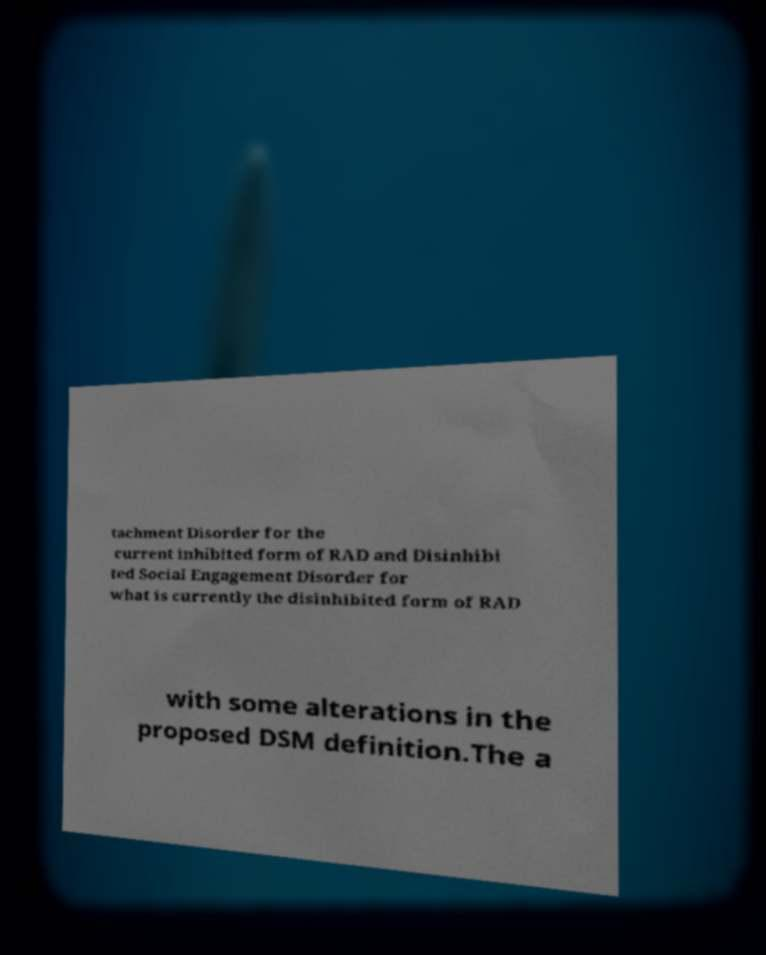There's text embedded in this image that I need extracted. Can you transcribe it verbatim? tachment Disorder for the current inhibited form of RAD and Disinhibi ted Social Engagement Disorder for what is currently the disinhibited form of RAD with some alterations in the proposed DSM definition.The a 